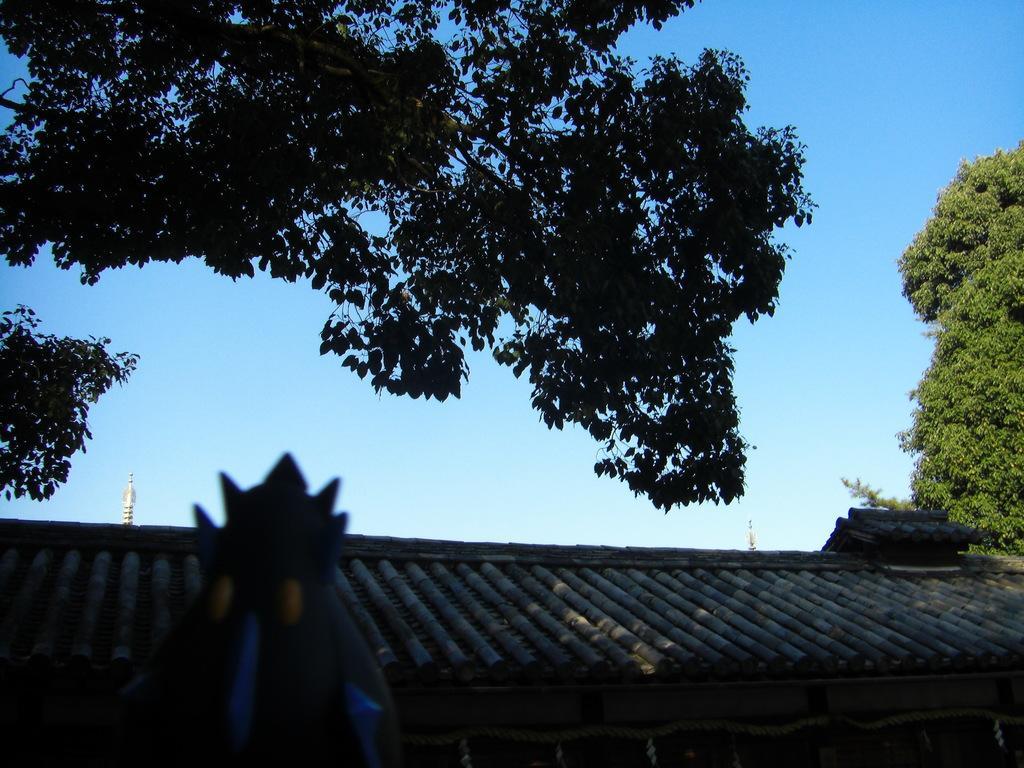Could you give a brief overview of what you see in this image? In this picture there is a building and there are roof tiles on the top of the building and there is a rope on the wall. In the foreground there is an object. At the back there are trees. At the top there is sky. 